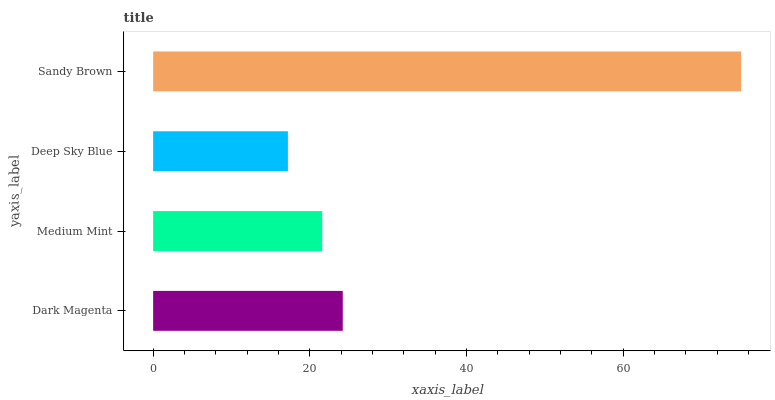Is Deep Sky Blue the minimum?
Answer yes or no. Yes. Is Sandy Brown the maximum?
Answer yes or no. Yes. Is Medium Mint the minimum?
Answer yes or no. No. Is Medium Mint the maximum?
Answer yes or no. No. Is Dark Magenta greater than Medium Mint?
Answer yes or no. Yes. Is Medium Mint less than Dark Magenta?
Answer yes or no. Yes. Is Medium Mint greater than Dark Magenta?
Answer yes or no. No. Is Dark Magenta less than Medium Mint?
Answer yes or no. No. Is Dark Magenta the high median?
Answer yes or no. Yes. Is Medium Mint the low median?
Answer yes or no. Yes. Is Sandy Brown the high median?
Answer yes or no. No. Is Dark Magenta the low median?
Answer yes or no. No. 